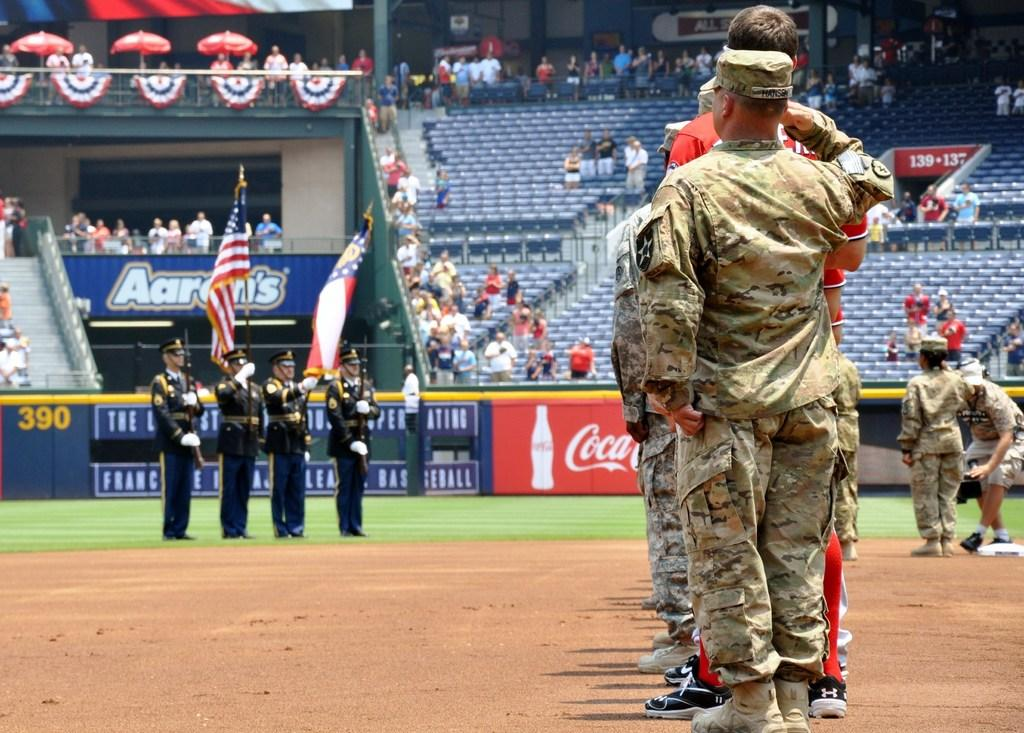<image>
Give a short and clear explanation of the subsequent image. The military guys are on a sports field holding flags and saluting with a Coca Cola advertisement on the banner. 